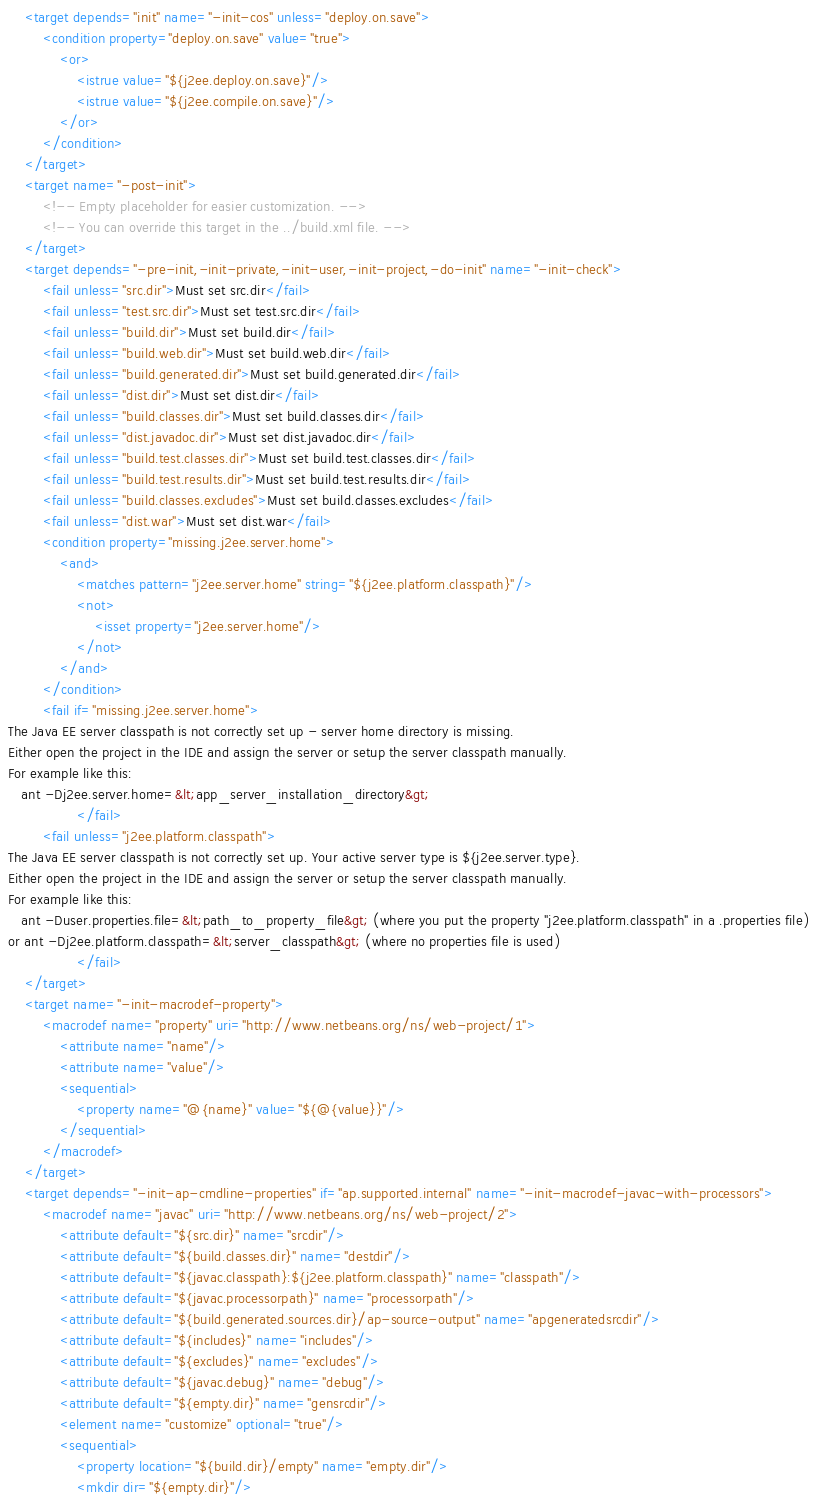<code> <loc_0><loc_0><loc_500><loc_500><_XML_>    <target depends="init" name="-init-cos" unless="deploy.on.save">
        <condition property="deploy.on.save" value="true">
            <or>
                <istrue value="${j2ee.deploy.on.save}"/>
                <istrue value="${j2ee.compile.on.save}"/>
            </or>
        </condition>
    </target>
    <target name="-post-init">
        <!-- Empty placeholder for easier customization. -->
        <!-- You can override this target in the ../build.xml file. -->
    </target>
    <target depends="-pre-init,-init-private,-init-user,-init-project,-do-init" name="-init-check">
        <fail unless="src.dir">Must set src.dir</fail>
        <fail unless="test.src.dir">Must set test.src.dir</fail>
        <fail unless="build.dir">Must set build.dir</fail>
        <fail unless="build.web.dir">Must set build.web.dir</fail>
        <fail unless="build.generated.dir">Must set build.generated.dir</fail>
        <fail unless="dist.dir">Must set dist.dir</fail>
        <fail unless="build.classes.dir">Must set build.classes.dir</fail>
        <fail unless="dist.javadoc.dir">Must set dist.javadoc.dir</fail>
        <fail unless="build.test.classes.dir">Must set build.test.classes.dir</fail>
        <fail unless="build.test.results.dir">Must set build.test.results.dir</fail>
        <fail unless="build.classes.excludes">Must set build.classes.excludes</fail>
        <fail unless="dist.war">Must set dist.war</fail>
        <condition property="missing.j2ee.server.home">
            <and>
                <matches pattern="j2ee.server.home" string="${j2ee.platform.classpath}"/>
                <not>
                    <isset property="j2ee.server.home"/>
                </not>
            </and>
        </condition>
        <fail if="missing.j2ee.server.home">
The Java EE server classpath is not correctly set up - server home directory is missing.
Either open the project in the IDE and assign the server or setup the server classpath manually.
For example like this:
   ant -Dj2ee.server.home=&lt;app_server_installation_directory&gt;
                </fail>
        <fail unless="j2ee.platform.classpath">
The Java EE server classpath is not correctly set up. Your active server type is ${j2ee.server.type}.
Either open the project in the IDE and assign the server or setup the server classpath manually.
For example like this:
   ant -Duser.properties.file=&lt;path_to_property_file&gt; (where you put the property "j2ee.platform.classpath" in a .properties file)
or ant -Dj2ee.platform.classpath=&lt;server_classpath&gt; (where no properties file is used)
                </fail>
    </target>
    <target name="-init-macrodef-property">
        <macrodef name="property" uri="http://www.netbeans.org/ns/web-project/1">
            <attribute name="name"/>
            <attribute name="value"/>
            <sequential>
                <property name="@{name}" value="${@{value}}"/>
            </sequential>
        </macrodef>
    </target>
    <target depends="-init-ap-cmdline-properties" if="ap.supported.internal" name="-init-macrodef-javac-with-processors">
        <macrodef name="javac" uri="http://www.netbeans.org/ns/web-project/2">
            <attribute default="${src.dir}" name="srcdir"/>
            <attribute default="${build.classes.dir}" name="destdir"/>
            <attribute default="${javac.classpath}:${j2ee.platform.classpath}" name="classpath"/>
            <attribute default="${javac.processorpath}" name="processorpath"/>
            <attribute default="${build.generated.sources.dir}/ap-source-output" name="apgeneratedsrcdir"/>
            <attribute default="${includes}" name="includes"/>
            <attribute default="${excludes}" name="excludes"/>
            <attribute default="${javac.debug}" name="debug"/>
            <attribute default="${empty.dir}" name="gensrcdir"/>
            <element name="customize" optional="true"/>
            <sequential>
                <property location="${build.dir}/empty" name="empty.dir"/>
                <mkdir dir="${empty.dir}"/></code> 